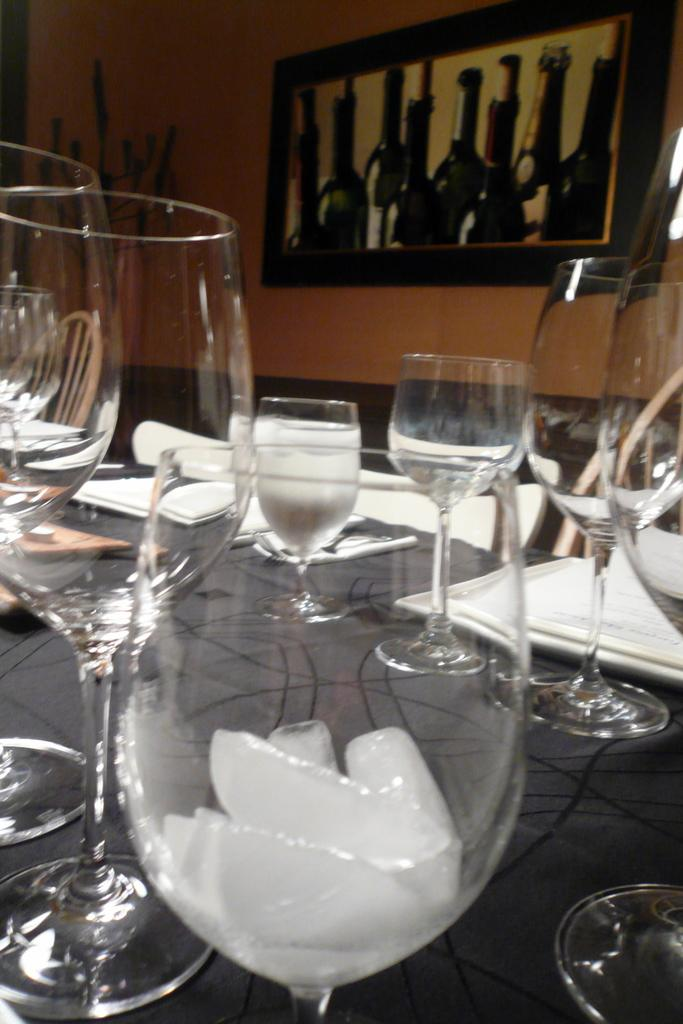What objects are on the table in the image? There are glasses and plates on the table in the image. What can be seen in the background of the image? There is a wall and a frame in the background of the image. What type of animal can be seen crossing the bridge in the image? There is no bridge or animal present in the image. 